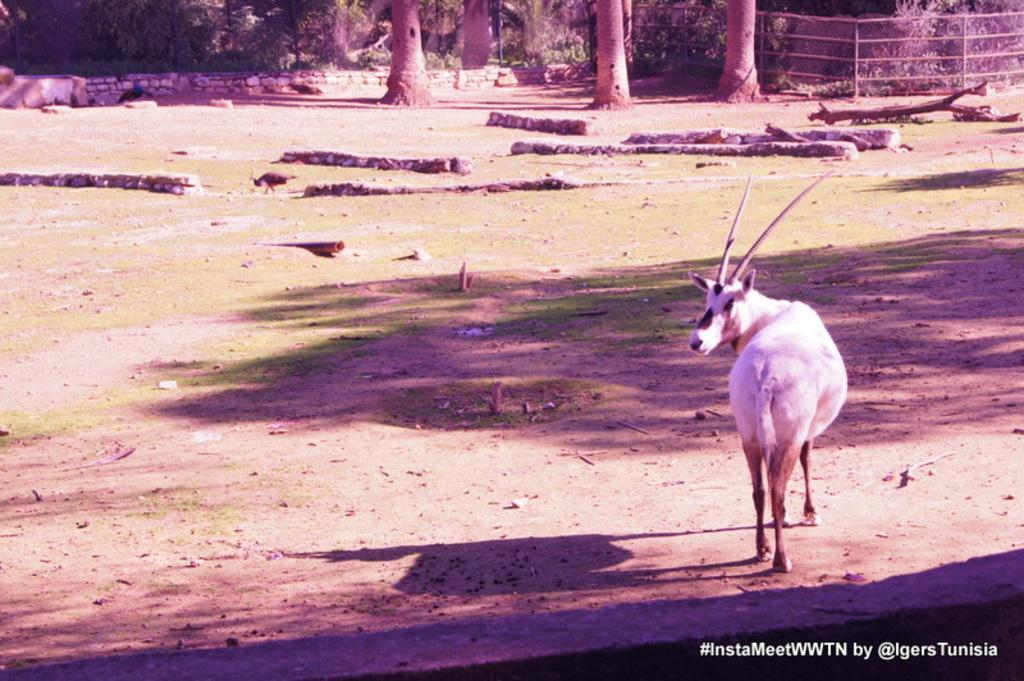Can you describe this image briefly? In the image there is an animal standing on a land and in front of the animal there are many trees and on the right side there is some wooden log. 